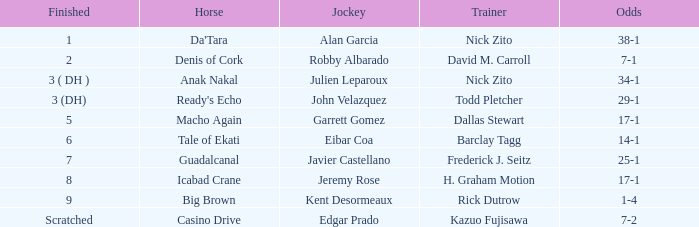Can you parse all the data within this table? {'header': ['Finished', 'Horse', 'Jockey', 'Trainer', 'Odds'], 'rows': [['1', "Da'Tara", 'Alan Garcia', 'Nick Zito', '38-1'], ['2', 'Denis of Cork', 'Robby Albarado', 'David M. Carroll', '7-1'], ['3 ( DH )', 'Anak Nakal', 'Julien Leparoux', 'Nick Zito', '34-1'], ['3 (DH)', "Ready's Echo", 'John Velazquez', 'Todd Pletcher', '29-1'], ['5', 'Macho Again', 'Garrett Gomez', 'Dallas Stewart', '17-1'], ['6', 'Tale of Ekati', 'Eibar Coa', 'Barclay Tagg', '14-1'], ['7', 'Guadalcanal', 'Javier Castellano', 'Frederick J. Seitz', '25-1'], ['8', 'Icabad Crane', 'Jeremy Rose', 'H. Graham Motion', '17-1'], ['9', 'Big Brown', 'Kent Desormeaux', 'Rick Dutrow', '1-4'], ['Scratched', 'Casino Drive', 'Edgar Prado', 'Kazuo Fujisawa', '7-2']]} How likely is it for ready's echo, the horse, to win? 29-1. 